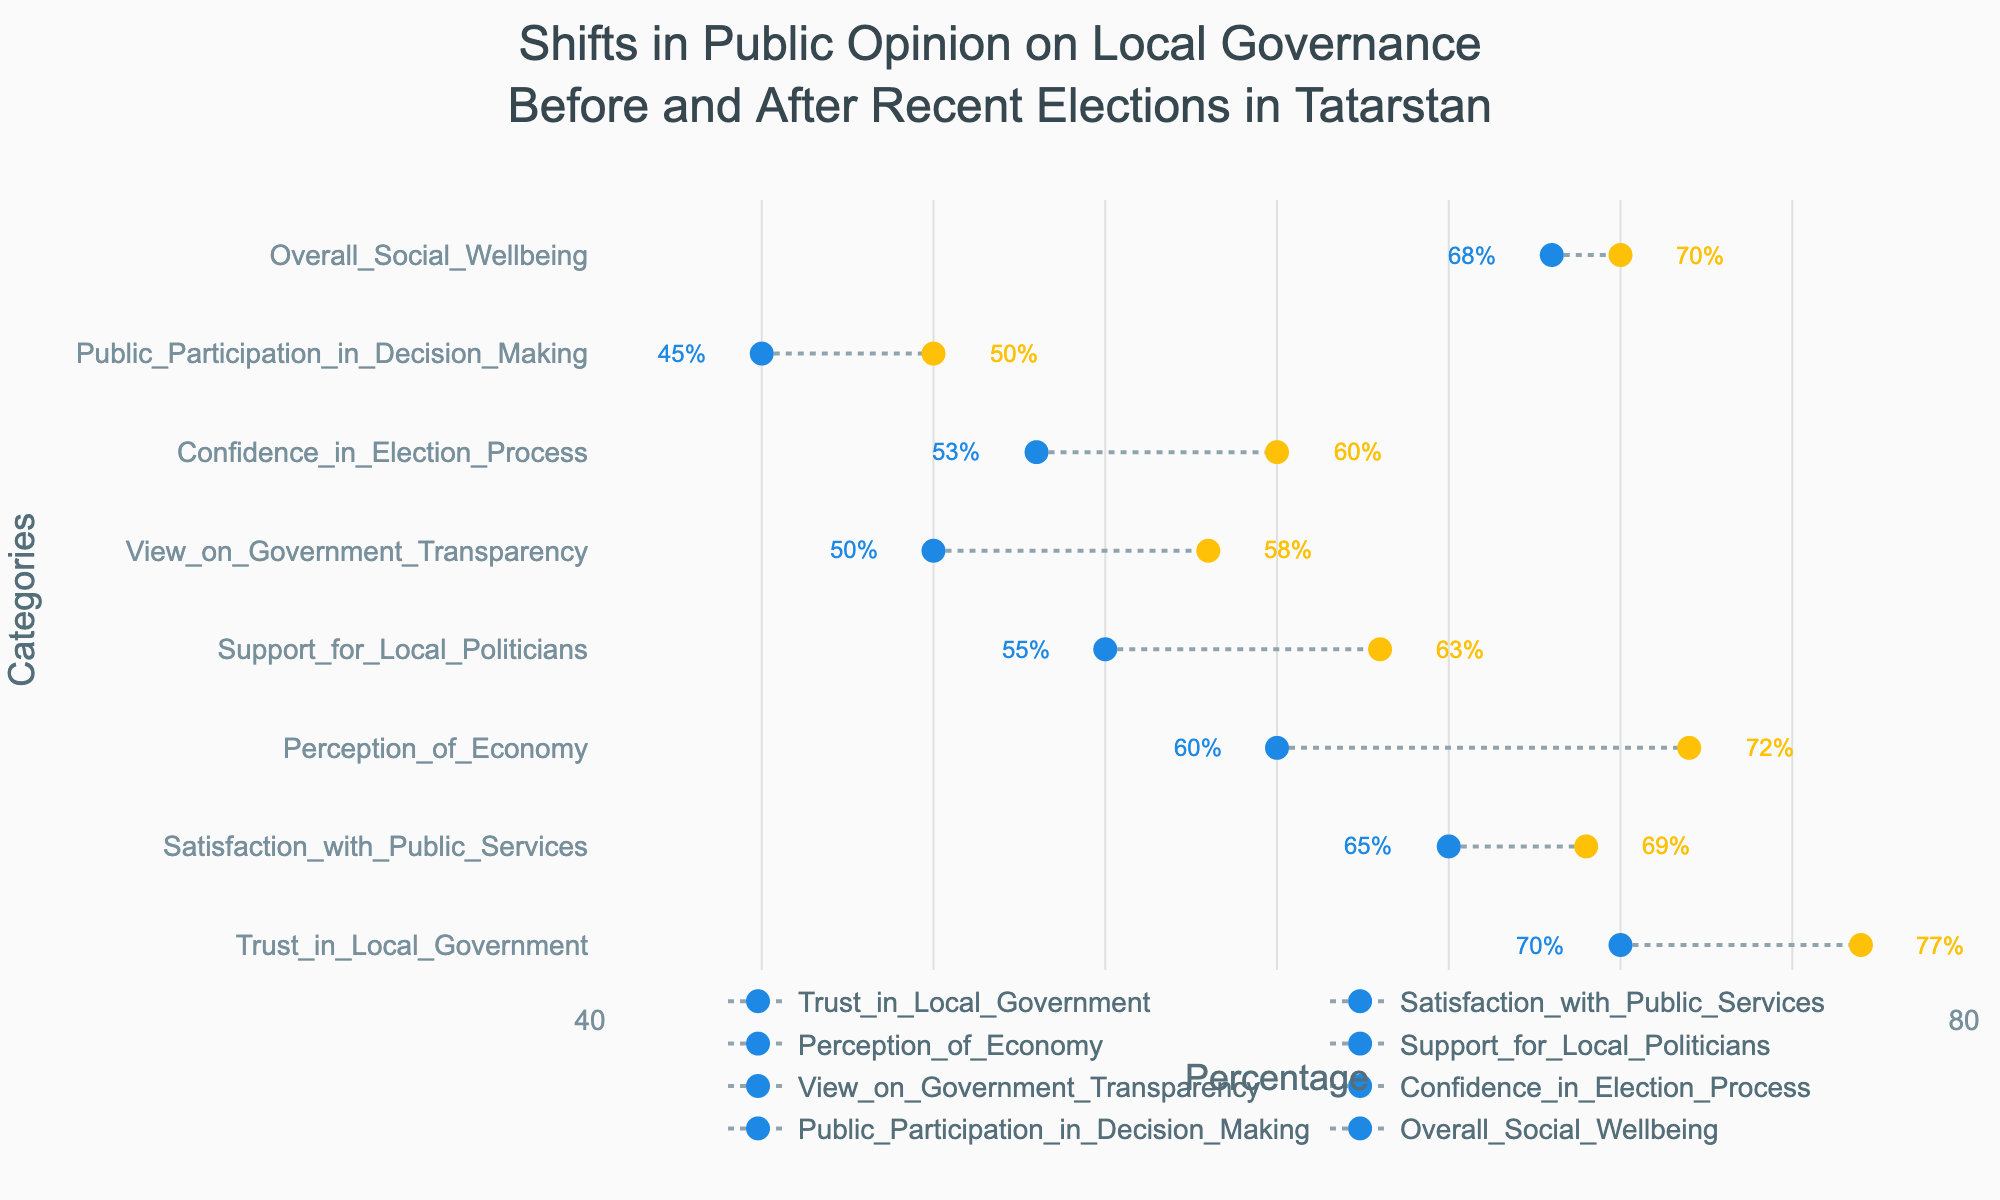How many categories are displayed in the figure? Count the number of unique categories listed on the y-axis. There are 8 categories shown.
Answer: 8 What is the percentage increase in Perception of the Economy? Subtract the value before the elections from the value after the elections for the Perception of the Economy category. The increase is 72% - 60% = 12%.
Answer: 12% Which category experienced the highest percentage increase after the elections? Compare the percentage increases for all categories. The Perception of the Economy increased the most, from 60% to 72%, which is a 12% increase.
Answer: Perception of the Economy What was the percentage of Satisfaction with Public Services before and after the elections? Refer to the data points for Satisfaction with Public Services. Before the elections, it was 65%, and after the elections, it was 69%.
Answer: Before: 65%, After: 69% Which category had the lowest percentage both before and after the elections? Identify the category with the lowest percentage values in both columns. Public Participation in Decision Making had the lowest percentages, with 45% before and 50% after the elections.
Answer: Public Participation in Decision Making What is the average percentage increase for all categories? Calculate the percentage increase for each category and then find the average of these increases. The average increase is [(7 + 4 + 12 + 8 + 8 + 7 + 5 + 2) / 8 = 6.625%].
Answer: 6.625% Did any category's percentage decrease after the elections? Check if any category's 'After Elections' percentage is lower than the 'Before Elections' percentage. No category shows a decrease in percentage after the elections.
Answer: No Compare the change in Trust in Local Government to the change in Confidence in Election Process. Calculate the percentage increase for both categories: Trust in Local Government (77% - 70% = 7%) and Confidence in Election Process (60% - 53% = 7%). Both increased by 7%.
Answer: Equal (7% increase each) How did the view on Government Transparency change over the elections? Calculate the difference in percentages before and after the elections for Government Transparency. The view on Government Transparency increased from 50% to 58%, which is an 8% increase.
Answer: Increased by 8% 